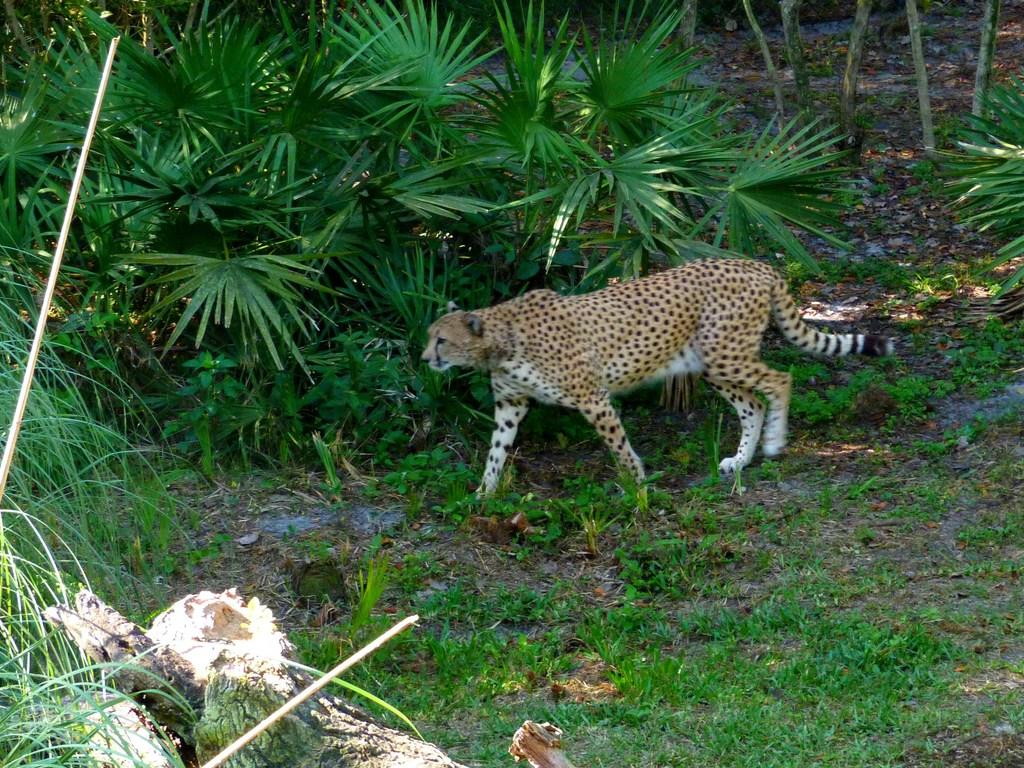What is the main subject in the center of the image? There is an animal in the center of the image. What is the animal doing in the image? The animal is walking. What can be seen in the background of the image? There are plants in the background of the image. What type of vegetation is on the ground in the front of the image? There is grass on the ground in the front of the image. What else can be seen on the left side of the image? There are leaves on the left side of the image. How does the animal express regret in the image? There is no indication of regret in the image; the animal is simply walking. 